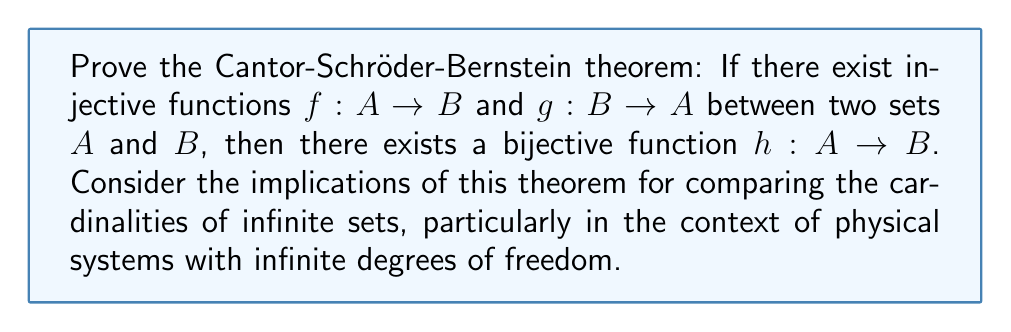What is the answer to this math problem? Let's approach this proof step-by-step:

1) First, we need to understand what the theorem states. It says that if we can inject $A$ into $B$ and $B$ into $A$, then $A$ and $B$ have the same cardinality.

2) We'll prove this by constructing a bijective function $h: A \to B$.

3) Define a sequence of sets:
   $$A_0 = A \setminus g(B)$$
   $$A_{n+1} = g(f(A_n)) \text{ for } n \geq 0$$

4) Let $C = \bigcup_{n=0}^{\infty} A_n$

5) Now, define $h: A \to B$ as follows:
   $$h(x) = \begin{cases} 
   f(x) & \text{if } x \in C \\
   g^{-1}(x) & \text{if } x \in A \setminus C
   \end{cases}$$

6) We need to prove that $h$ is bijective:

   a) $h$ is injective:
      - If $x, y \in C$, then $h(x) = h(y)$ implies $f(x) = f(y)$, which implies $x = y$ since $f$ is injective.
      - If $x, y \in A \setminus C$, then $h(x) = h(y)$ implies $g^{-1}(x) = g^{-1}(y)$, which implies $x = y$.
      - If $x \in C$ and $y \in A \setminus C$, then $h(x) = f(x) \neq g^{-1}(y) = h(y)$.

   b) $h$ is surjective:
      - For any $y \in B$, either $g(y) \in C$ or $g(y) \in A \setminus C$.
      - If $g(y) \in C$, then $g(y) \in A_n$ for some $n$. So $y = f(x)$ for some $x \in A_{n-1}$, and $h(x) = f(x) = y$.
      - If $g(y) \in A \setminus C$, then $h(g(y)) = g^{-1}(g(y)) = y$.

7) Therefore, $h$ is bijective, proving the theorem.

In the context of physical systems with infinite degrees of freedom, this theorem has profound implications. It allows us to compare the "sizes" of different infinities, which is crucial in quantum field theory and statistical mechanics. For instance, it helps in comparing the cardinality of the set of all possible quantum states in different systems, or in understanding the phase space of systems with infinite particles.
Answer: The Cantor-Schröder-Bernstein theorem is proven by constructing a bijective function $h: A \to B$ using the given injective functions $f: A \to B$ and $g: B \to A$. The function $h$ is defined piecewise on a carefully constructed partition of $A$, ensuring both injectivity and surjectivity. This theorem allows for the comparison of cardinalities of infinite sets, which has important applications in physics, particularly in systems with infinite degrees of freedom. 